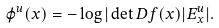Convert formula to latex. <formula><loc_0><loc_0><loc_500><loc_500>\varphi ^ { u } ( x ) = - \log | \det D f ( x ) | E ^ { u } _ { x } | .</formula> 